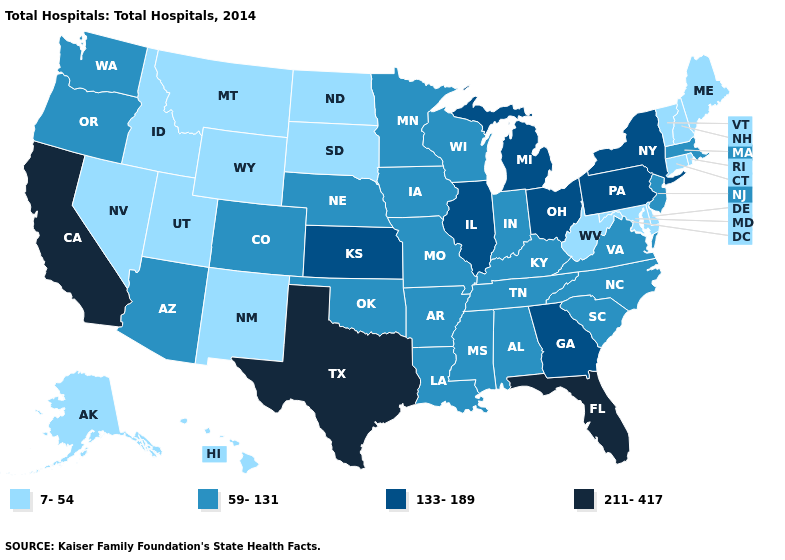Does Missouri have a lower value than Wisconsin?
Write a very short answer. No. How many symbols are there in the legend?
Concise answer only. 4. Does Connecticut have the same value as Kentucky?
Quick response, please. No. Among the states that border Arkansas , which have the lowest value?
Short answer required. Louisiana, Mississippi, Missouri, Oklahoma, Tennessee. Which states have the highest value in the USA?
Answer briefly. California, Florida, Texas. How many symbols are there in the legend?
Quick response, please. 4. Does Virginia have a higher value than New Mexico?
Concise answer only. Yes. Name the states that have a value in the range 211-417?
Short answer required. California, Florida, Texas. Name the states that have a value in the range 133-189?
Be succinct. Georgia, Illinois, Kansas, Michigan, New York, Ohio, Pennsylvania. Among the states that border Pennsylvania , which have the highest value?
Quick response, please. New York, Ohio. What is the value of South Carolina?
Write a very short answer. 59-131. Among the states that border Connecticut , which have the lowest value?
Short answer required. Rhode Island. What is the value of Nevada?
Answer briefly. 7-54. Among the states that border Texas , does Arkansas have the highest value?
Answer briefly. Yes. Which states have the highest value in the USA?
Concise answer only. California, Florida, Texas. 